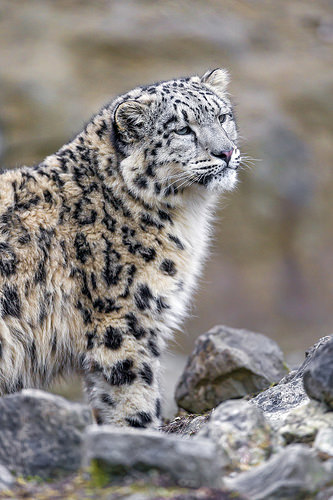<image>
Can you confirm if the tiger is on the stone? Yes. Looking at the image, I can see the tiger is positioned on top of the stone, with the stone providing support. Is the snow leopard in the rock? No. The snow leopard is not contained within the rock. These objects have a different spatial relationship. 